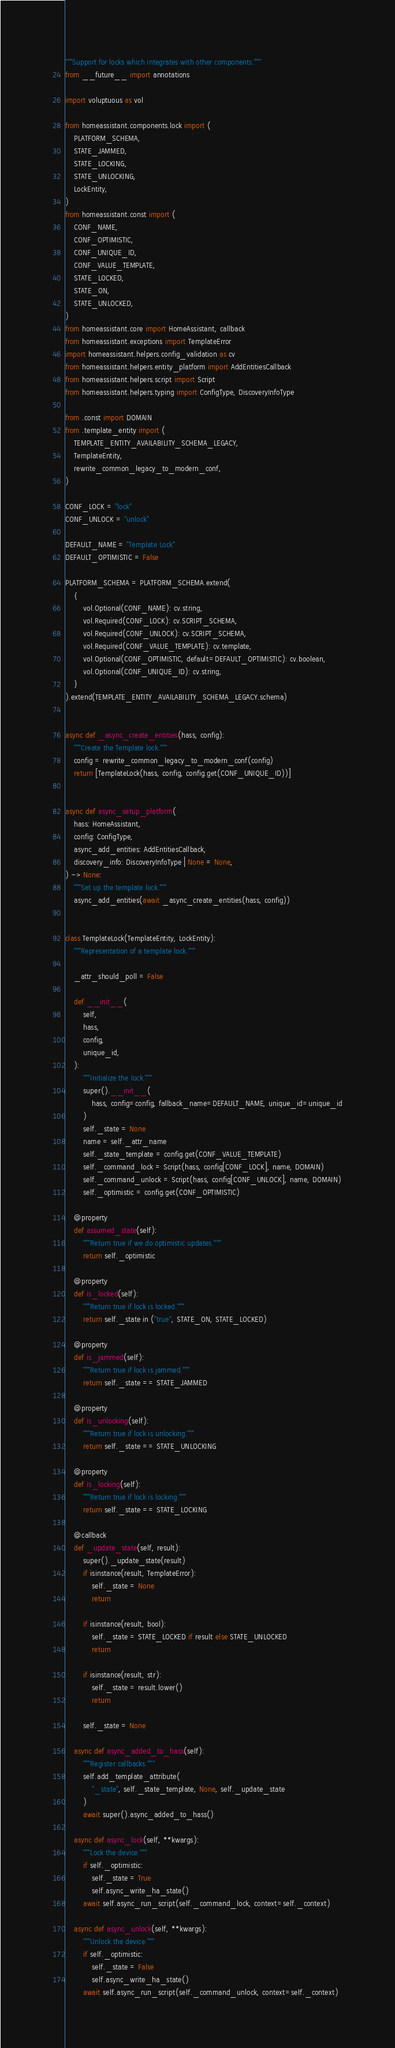Convert code to text. <code><loc_0><loc_0><loc_500><loc_500><_Python_>"""Support for locks which integrates with other components."""
from __future__ import annotations

import voluptuous as vol

from homeassistant.components.lock import (
    PLATFORM_SCHEMA,
    STATE_JAMMED,
    STATE_LOCKING,
    STATE_UNLOCKING,
    LockEntity,
)
from homeassistant.const import (
    CONF_NAME,
    CONF_OPTIMISTIC,
    CONF_UNIQUE_ID,
    CONF_VALUE_TEMPLATE,
    STATE_LOCKED,
    STATE_ON,
    STATE_UNLOCKED,
)
from homeassistant.core import HomeAssistant, callback
from homeassistant.exceptions import TemplateError
import homeassistant.helpers.config_validation as cv
from homeassistant.helpers.entity_platform import AddEntitiesCallback
from homeassistant.helpers.script import Script
from homeassistant.helpers.typing import ConfigType, DiscoveryInfoType

from .const import DOMAIN
from .template_entity import (
    TEMPLATE_ENTITY_AVAILABILITY_SCHEMA_LEGACY,
    TemplateEntity,
    rewrite_common_legacy_to_modern_conf,
)

CONF_LOCK = "lock"
CONF_UNLOCK = "unlock"

DEFAULT_NAME = "Template Lock"
DEFAULT_OPTIMISTIC = False

PLATFORM_SCHEMA = PLATFORM_SCHEMA.extend(
    {
        vol.Optional(CONF_NAME): cv.string,
        vol.Required(CONF_LOCK): cv.SCRIPT_SCHEMA,
        vol.Required(CONF_UNLOCK): cv.SCRIPT_SCHEMA,
        vol.Required(CONF_VALUE_TEMPLATE): cv.template,
        vol.Optional(CONF_OPTIMISTIC, default=DEFAULT_OPTIMISTIC): cv.boolean,
        vol.Optional(CONF_UNIQUE_ID): cv.string,
    }
).extend(TEMPLATE_ENTITY_AVAILABILITY_SCHEMA_LEGACY.schema)


async def _async_create_entities(hass, config):
    """Create the Template lock."""
    config = rewrite_common_legacy_to_modern_conf(config)
    return [TemplateLock(hass, config, config.get(CONF_UNIQUE_ID))]


async def async_setup_platform(
    hass: HomeAssistant,
    config: ConfigType,
    async_add_entities: AddEntitiesCallback,
    discovery_info: DiscoveryInfoType | None = None,
) -> None:
    """Set up the template lock."""
    async_add_entities(await _async_create_entities(hass, config))


class TemplateLock(TemplateEntity, LockEntity):
    """Representation of a template lock."""

    _attr_should_poll = False

    def __init__(
        self,
        hass,
        config,
        unique_id,
    ):
        """Initialize the lock."""
        super().__init__(
            hass, config=config, fallback_name=DEFAULT_NAME, unique_id=unique_id
        )
        self._state = None
        name = self._attr_name
        self._state_template = config.get(CONF_VALUE_TEMPLATE)
        self._command_lock = Script(hass, config[CONF_LOCK], name, DOMAIN)
        self._command_unlock = Script(hass, config[CONF_UNLOCK], name, DOMAIN)
        self._optimistic = config.get(CONF_OPTIMISTIC)

    @property
    def assumed_state(self):
        """Return true if we do optimistic updates."""
        return self._optimistic

    @property
    def is_locked(self):
        """Return true if lock is locked."""
        return self._state in ("true", STATE_ON, STATE_LOCKED)

    @property
    def is_jammed(self):
        """Return true if lock is jammed."""
        return self._state == STATE_JAMMED

    @property
    def is_unlocking(self):
        """Return true if lock is unlocking."""
        return self._state == STATE_UNLOCKING

    @property
    def is_locking(self):
        """Return true if lock is locking."""
        return self._state == STATE_LOCKING

    @callback
    def _update_state(self, result):
        super()._update_state(result)
        if isinstance(result, TemplateError):
            self._state = None
            return

        if isinstance(result, bool):
            self._state = STATE_LOCKED if result else STATE_UNLOCKED
            return

        if isinstance(result, str):
            self._state = result.lower()
            return

        self._state = None

    async def async_added_to_hass(self):
        """Register callbacks."""
        self.add_template_attribute(
            "_state", self._state_template, None, self._update_state
        )
        await super().async_added_to_hass()

    async def async_lock(self, **kwargs):
        """Lock the device."""
        if self._optimistic:
            self._state = True
            self.async_write_ha_state()
        await self.async_run_script(self._command_lock, context=self._context)

    async def async_unlock(self, **kwargs):
        """Unlock the device."""
        if self._optimistic:
            self._state = False
            self.async_write_ha_state()
        await self.async_run_script(self._command_unlock, context=self._context)
</code> 